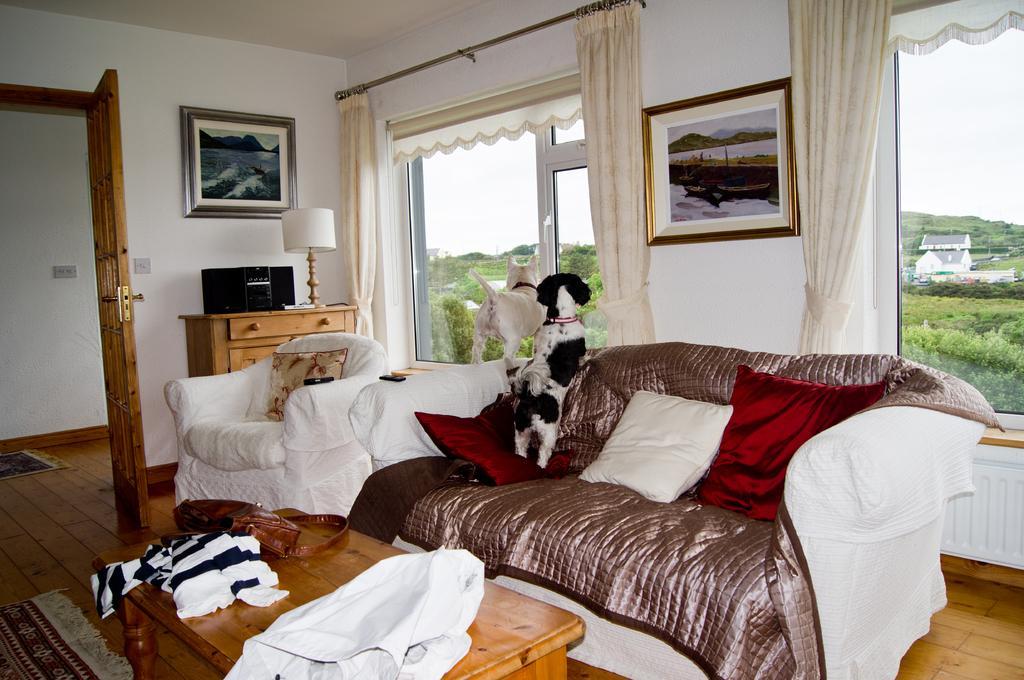Can you describe this image briefly? In this image I can see a sofa and a chair. Here I can see two animals on it. On this wall I can see few frames. Here I can see number of trees and number of buildings. 